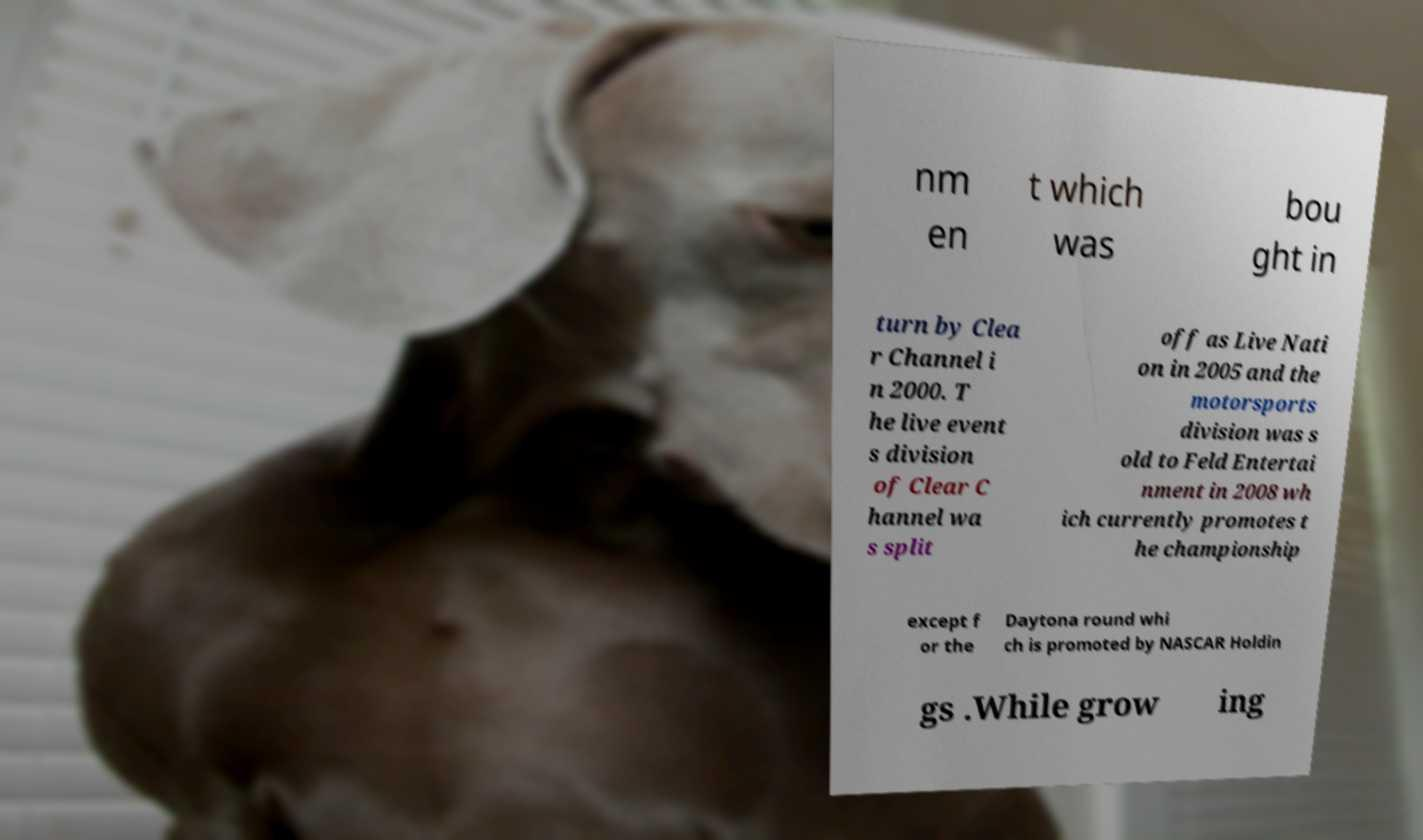There's text embedded in this image that I need extracted. Can you transcribe it verbatim? nm en t which was bou ght in turn by Clea r Channel i n 2000. T he live event s division of Clear C hannel wa s split off as Live Nati on in 2005 and the motorsports division was s old to Feld Entertai nment in 2008 wh ich currently promotes t he championship except f or the Daytona round whi ch is promoted by NASCAR Holdin gs .While grow ing 